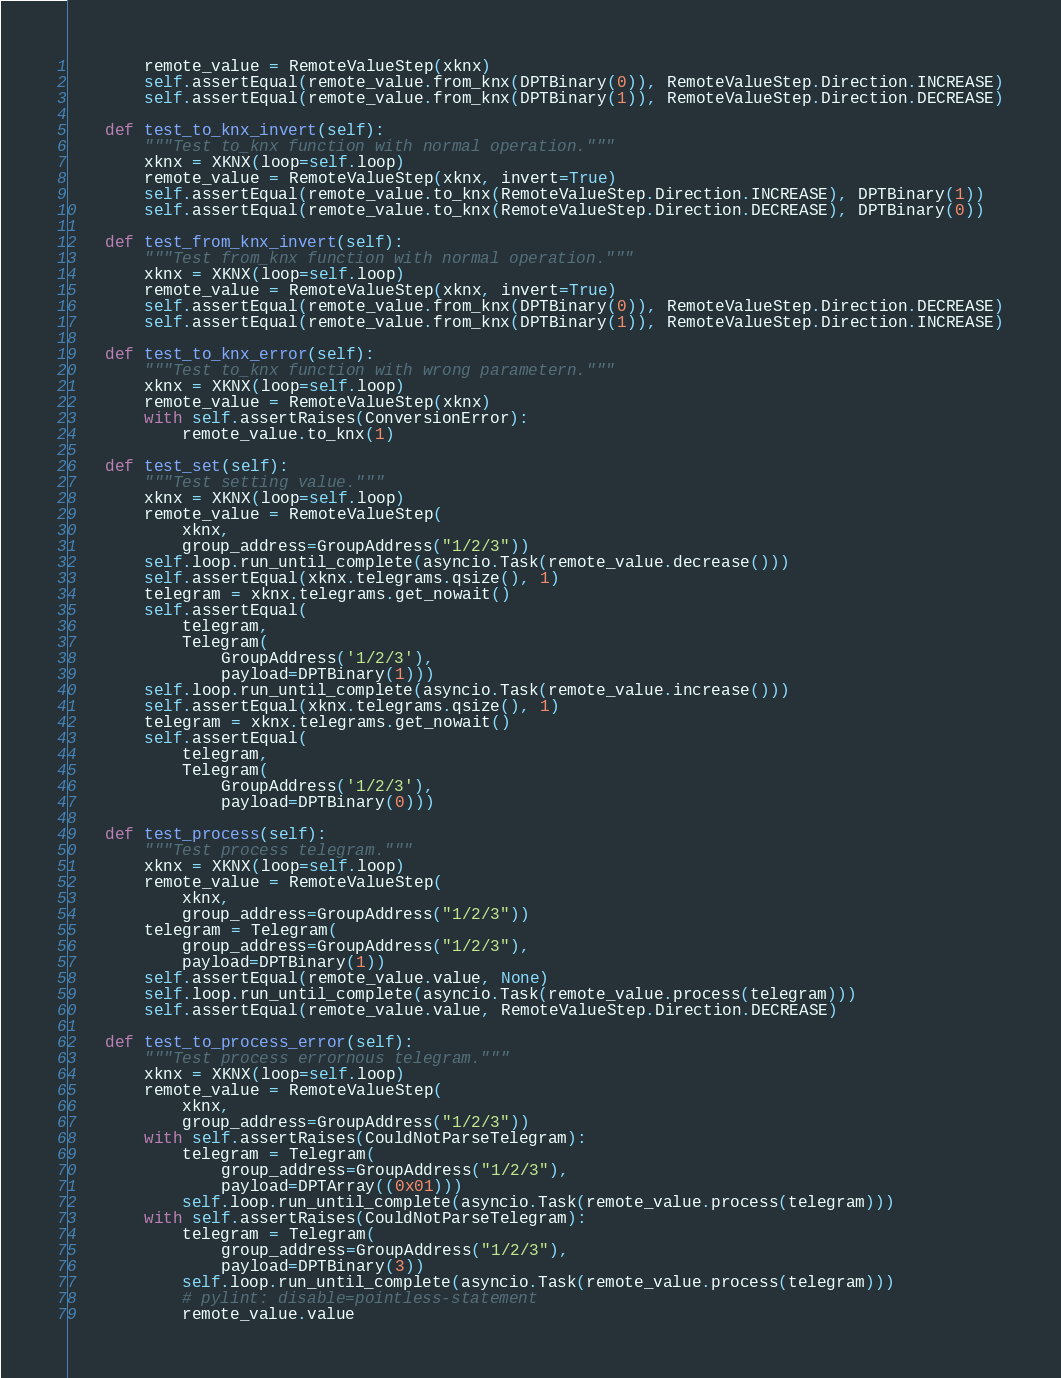<code> <loc_0><loc_0><loc_500><loc_500><_Python_>        remote_value = RemoteValueStep(xknx)
        self.assertEqual(remote_value.from_knx(DPTBinary(0)), RemoteValueStep.Direction.INCREASE)
        self.assertEqual(remote_value.from_knx(DPTBinary(1)), RemoteValueStep.Direction.DECREASE)

    def test_to_knx_invert(self):
        """Test to_knx function with normal operation."""
        xknx = XKNX(loop=self.loop)
        remote_value = RemoteValueStep(xknx, invert=True)
        self.assertEqual(remote_value.to_knx(RemoteValueStep.Direction.INCREASE), DPTBinary(1))
        self.assertEqual(remote_value.to_knx(RemoteValueStep.Direction.DECREASE), DPTBinary(0))

    def test_from_knx_invert(self):
        """Test from_knx function with normal operation."""
        xknx = XKNX(loop=self.loop)
        remote_value = RemoteValueStep(xknx, invert=True)
        self.assertEqual(remote_value.from_knx(DPTBinary(0)), RemoteValueStep.Direction.DECREASE)
        self.assertEqual(remote_value.from_knx(DPTBinary(1)), RemoteValueStep.Direction.INCREASE)

    def test_to_knx_error(self):
        """Test to_knx function with wrong parametern."""
        xknx = XKNX(loop=self.loop)
        remote_value = RemoteValueStep(xknx)
        with self.assertRaises(ConversionError):
            remote_value.to_knx(1)

    def test_set(self):
        """Test setting value."""
        xknx = XKNX(loop=self.loop)
        remote_value = RemoteValueStep(
            xknx,
            group_address=GroupAddress("1/2/3"))
        self.loop.run_until_complete(asyncio.Task(remote_value.decrease()))
        self.assertEqual(xknx.telegrams.qsize(), 1)
        telegram = xknx.telegrams.get_nowait()
        self.assertEqual(
            telegram,
            Telegram(
                GroupAddress('1/2/3'),
                payload=DPTBinary(1)))
        self.loop.run_until_complete(asyncio.Task(remote_value.increase()))
        self.assertEqual(xknx.telegrams.qsize(), 1)
        telegram = xknx.telegrams.get_nowait()
        self.assertEqual(
            telegram,
            Telegram(
                GroupAddress('1/2/3'),
                payload=DPTBinary(0)))

    def test_process(self):
        """Test process telegram."""
        xknx = XKNX(loop=self.loop)
        remote_value = RemoteValueStep(
            xknx,
            group_address=GroupAddress("1/2/3"))
        telegram = Telegram(
            group_address=GroupAddress("1/2/3"),
            payload=DPTBinary(1))
        self.assertEqual(remote_value.value, None)
        self.loop.run_until_complete(asyncio.Task(remote_value.process(telegram)))
        self.assertEqual(remote_value.value, RemoteValueStep.Direction.DECREASE)

    def test_to_process_error(self):
        """Test process errornous telegram."""
        xknx = XKNX(loop=self.loop)
        remote_value = RemoteValueStep(
            xknx,
            group_address=GroupAddress("1/2/3"))
        with self.assertRaises(CouldNotParseTelegram):
            telegram = Telegram(
                group_address=GroupAddress("1/2/3"),
                payload=DPTArray((0x01)))
            self.loop.run_until_complete(asyncio.Task(remote_value.process(telegram)))
        with self.assertRaises(CouldNotParseTelegram):
            telegram = Telegram(
                group_address=GroupAddress("1/2/3"),
                payload=DPTBinary(3))
            self.loop.run_until_complete(asyncio.Task(remote_value.process(telegram)))
            # pylint: disable=pointless-statement
            remote_value.value
</code> 